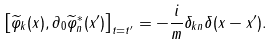<formula> <loc_0><loc_0><loc_500><loc_500>\left [ \widetilde { \varphi } _ { k } ( x ) , \partial _ { 0 } \widetilde { \varphi } _ { n } ^ { * } ( x ^ { \prime } ) \right ] _ { t = t ^ { \prime } } = - \frac { i } { m } \delta _ { k n } \delta ( x - x ^ { \prime } ) .</formula> 